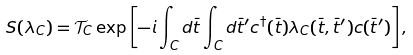Convert formula to latex. <formula><loc_0><loc_0><loc_500><loc_500>S ( \lambda _ { C } ) = \mathcal { T } _ { C } \exp \left [ - i \int _ { C } d \bar { t } \int _ { C } d \bar { t } ^ { \prime } c ^ { \dagger } ( \bar { t } ) \lambda _ { C } ( \bar { t } , \bar { t } ^ { \prime } ) c ( \bar { t } ^ { \prime } ) \right ] ,</formula> 